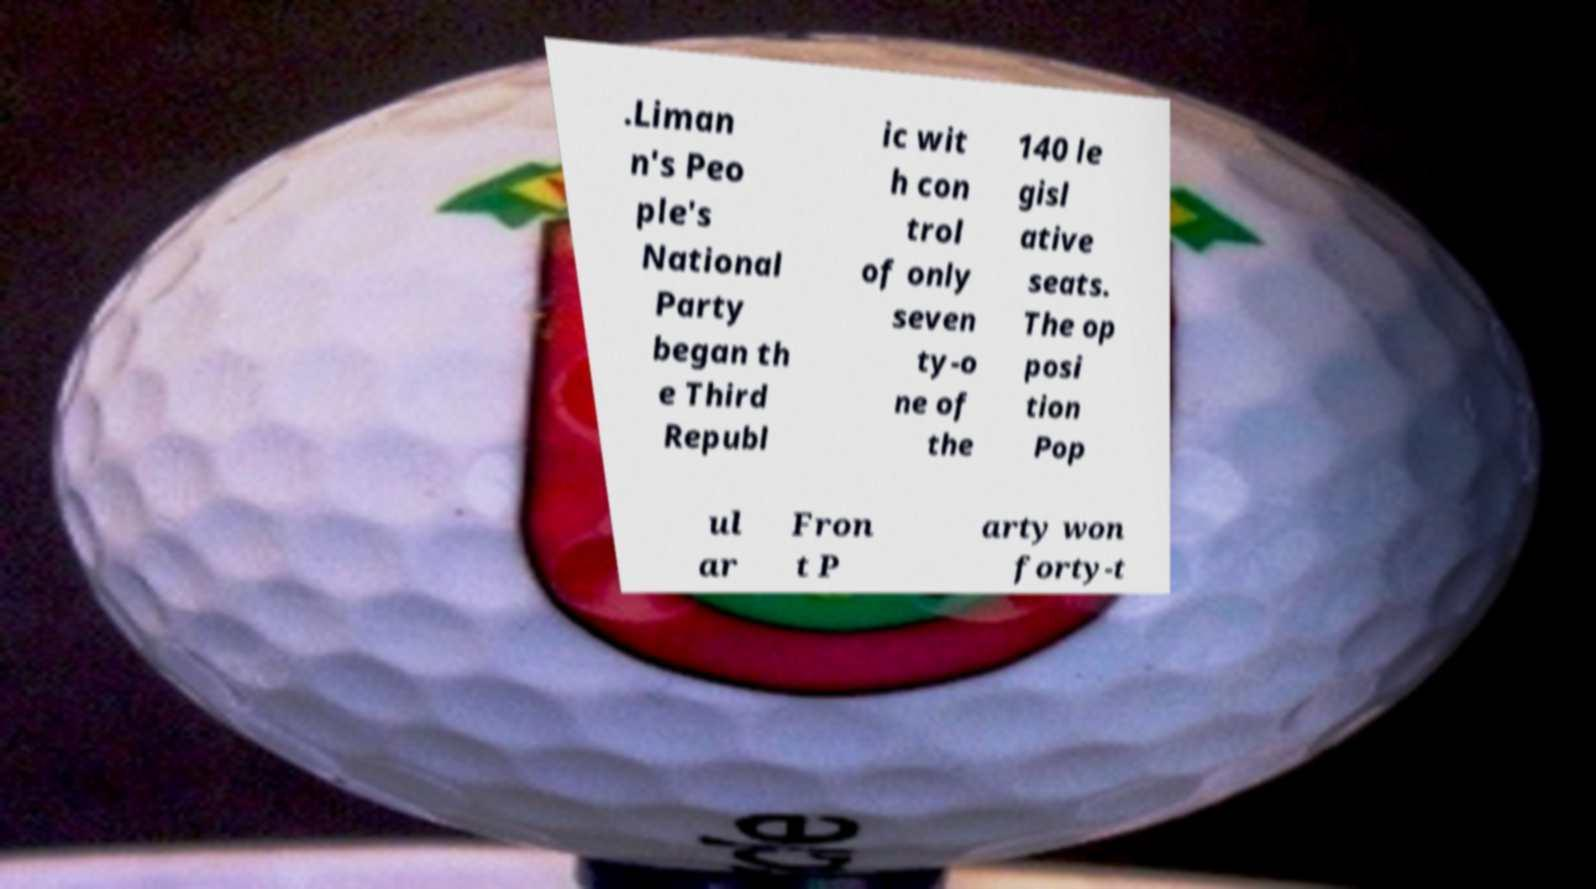I need the written content from this picture converted into text. Can you do that? .Liman n's Peo ple's National Party began th e Third Republ ic wit h con trol of only seven ty-o ne of the 140 le gisl ative seats. The op posi tion Pop ul ar Fron t P arty won forty-t 